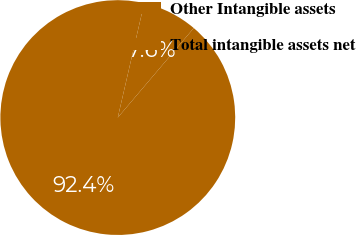Convert chart. <chart><loc_0><loc_0><loc_500><loc_500><pie_chart><fcel>Other Intangible assets<fcel>Total intangible assets net<nl><fcel>7.59%<fcel>92.41%<nl></chart> 